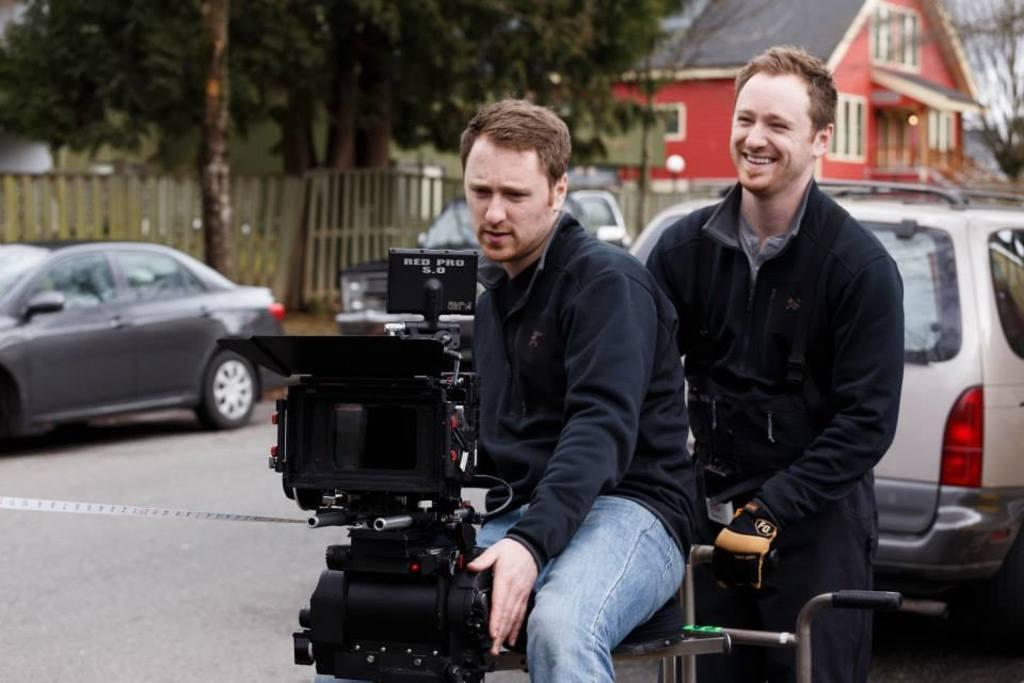How many men are in the image? There are two men in the image. Can you describe the expressions of the men? One of the men is smiling. What is one of the men holding in the image? One of the men is holding an equipment. What can be seen in the background of the image? There are cars, a road, a house, a fence, and trees visible in the background. What type of suit is the man wearing in the image? There is no mention of a suit in the image; the men are not wearing suits. Can you tell me how many carts are visible in the image? There are no carts present in the image. 